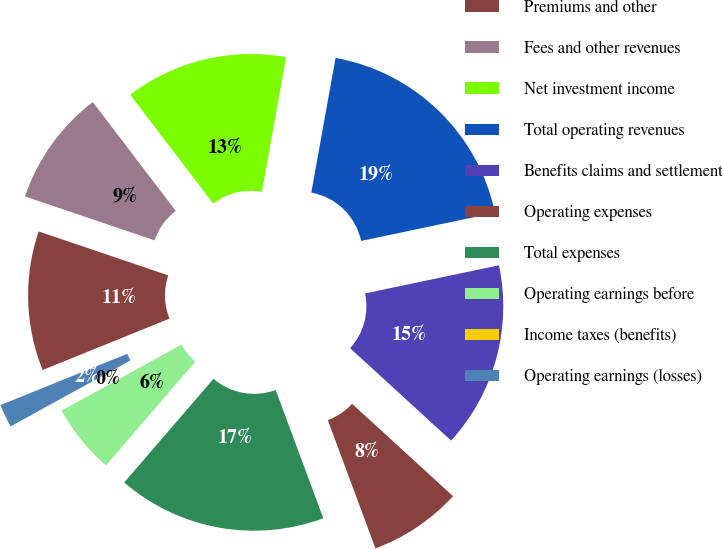Convert chart. <chart><loc_0><loc_0><loc_500><loc_500><pie_chart><fcel>Premiums and other<fcel>Fees and other revenues<fcel>Net investment income<fcel>Total operating revenues<fcel>Benefits claims and settlement<fcel>Operating expenses<fcel>Total expenses<fcel>Operating earnings before<fcel>Income taxes (benefits)<fcel>Operating earnings (losses)<nl><fcel>11.32%<fcel>9.43%<fcel>13.2%<fcel>18.86%<fcel>15.09%<fcel>7.55%<fcel>16.97%<fcel>5.66%<fcel>0.01%<fcel>1.89%<nl></chart> 